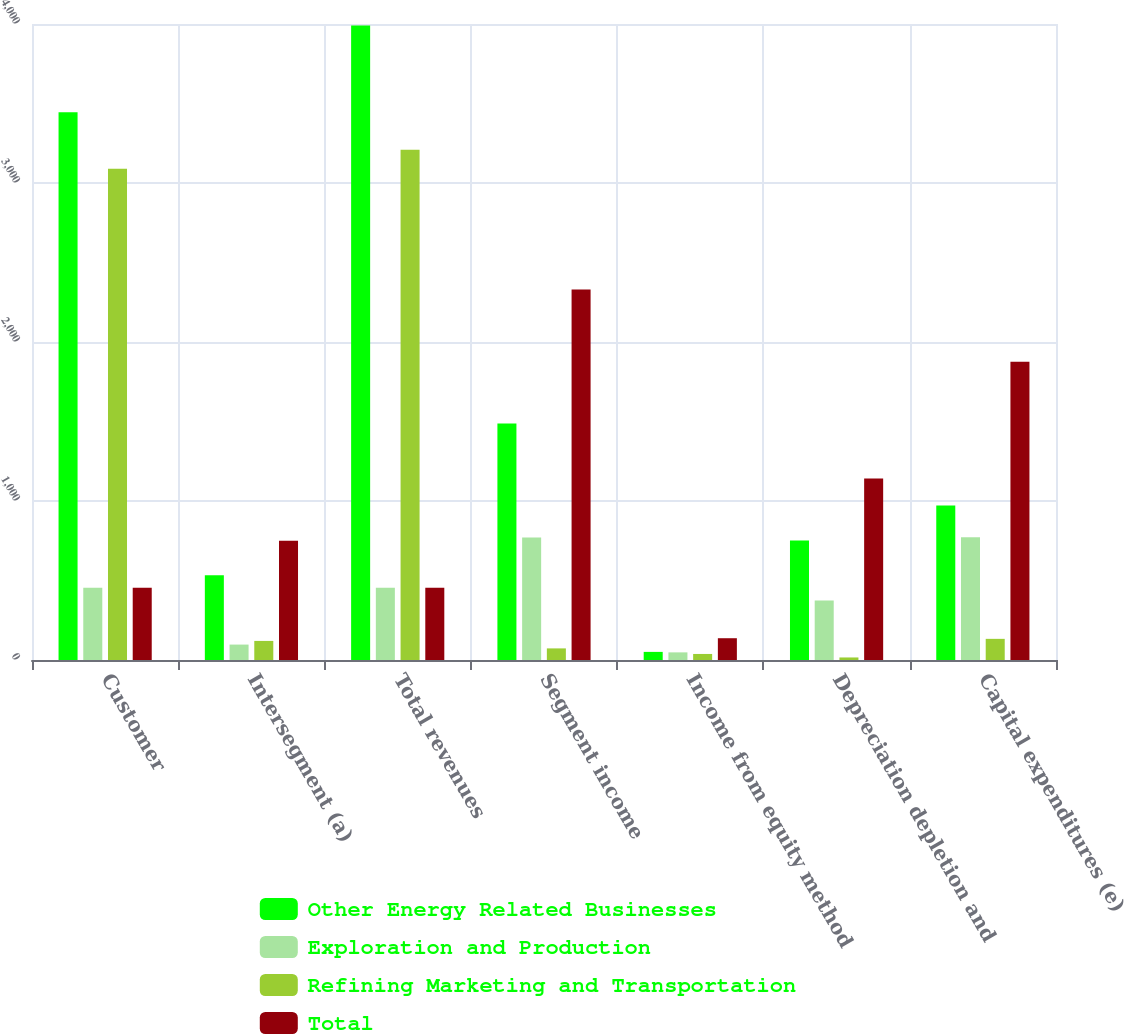Convert chart to OTSL. <chart><loc_0><loc_0><loc_500><loc_500><stacked_bar_chart><ecel><fcel>Customer<fcel>Intersegment (a)<fcel>Total revenues<fcel>Segment income<fcel>Income from equity method<fcel>Depreciation depletion and<fcel>Capital expenditures (e)<nl><fcel>Other Energy Related Businesses<fcel>3445<fcel>533<fcel>3990<fcel>1487<fcel>51<fcel>751<fcel>971<nl><fcel>Exploration and Production<fcel>454<fcel>97<fcel>454<fcel>770<fcel>48<fcel>375<fcel>772<nl><fcel>Refining Marketing and Transportation<fcel>3089<fcel>120<fcel>3209<fcel>73<fcel>38<fcel>16<fcel>133<nl><fcel>Total<fcel>454<fcel>750<fcel>454<fcel>2330<fcel>137<fcel>1142<fcel>1876<nl></chart> 